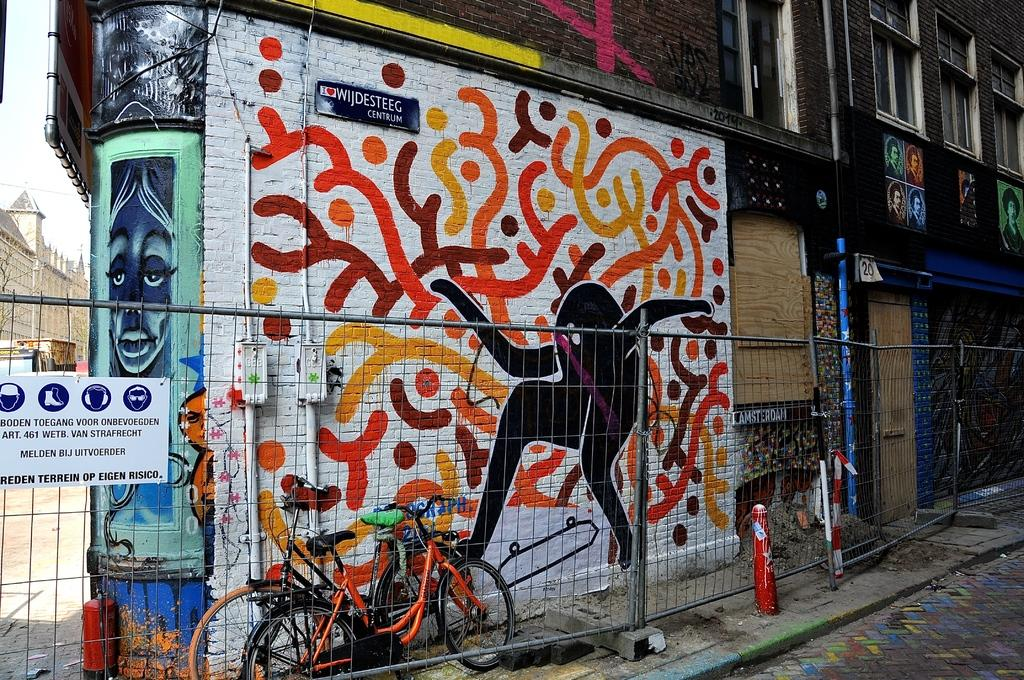What is the main feature of the image? There is a road in the image. What can be seen beside the road? There is a metal fence beside the road. What is visible in the background of the image? There are cycles, buildings, and the sky visible in the background of the image. Can you see any ghosts sleeping on their knees in the image? There are no ghosts or any indication of sleeping or knees in the image. 